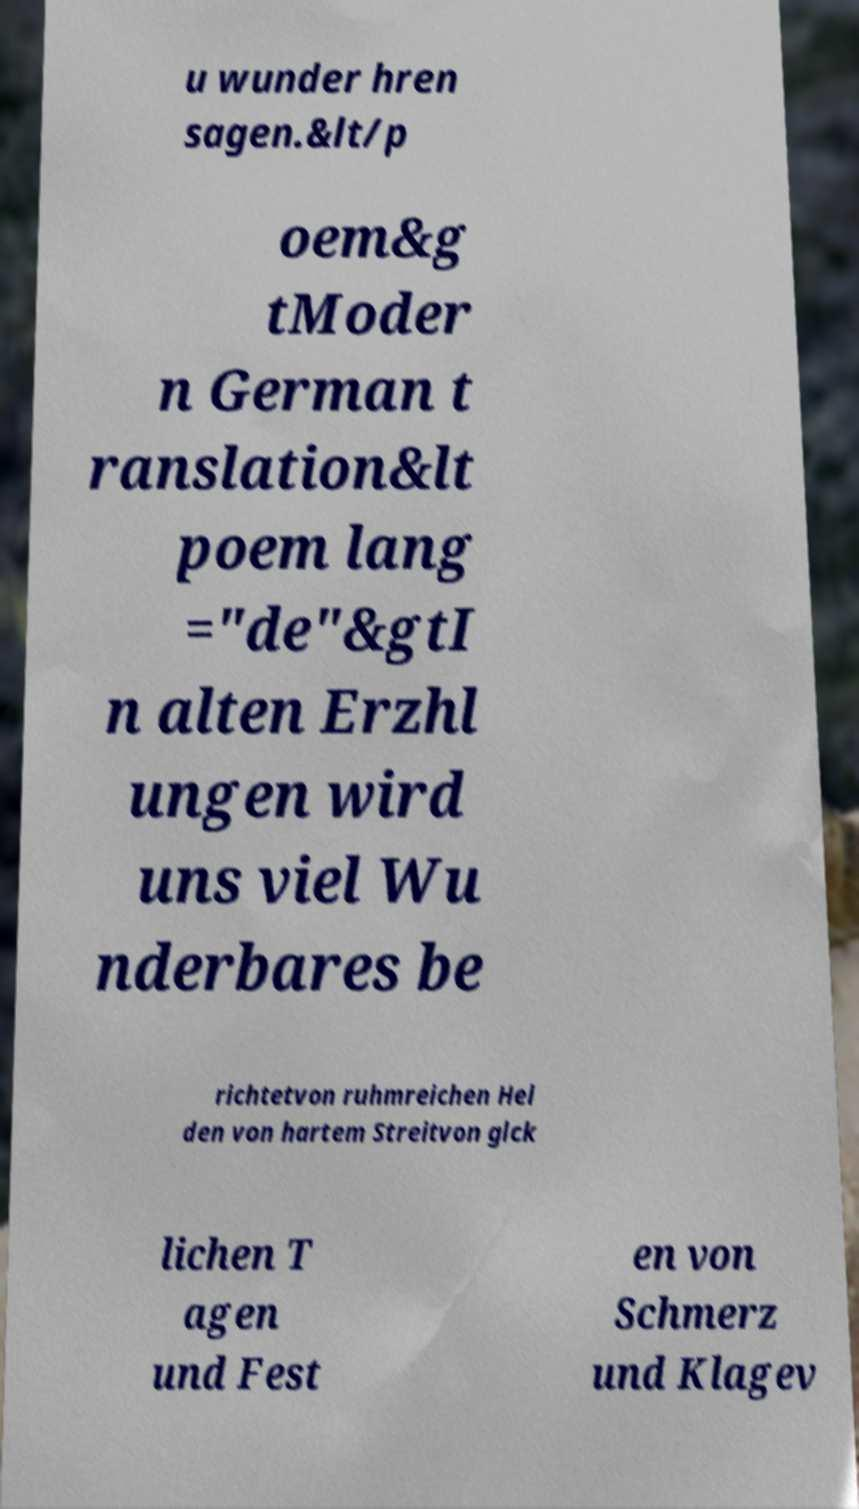Could you assist in decoding the text presented in this image and type it out clearly? u wunder hren sagen.&lt/p oem&g tModer n German t ranslation&lt poem lang ="de"&gtI n alten Erzhl ungen wird uns viel Wu nderbares be richtetvon ruhmreichen Hel den von hartem Streitvon glck lichen T agen und Fest en von Schmerz und Klagev 